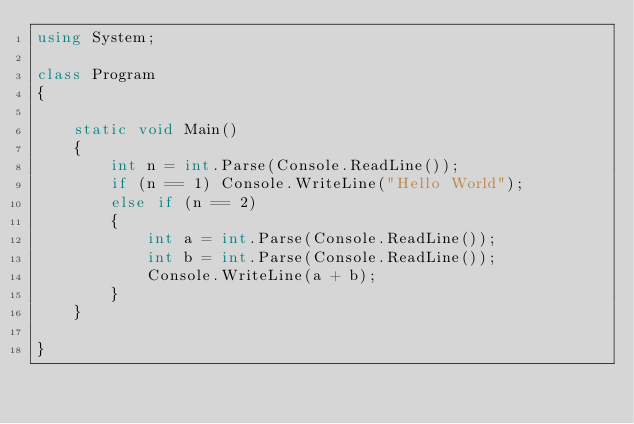<code> <loc_0><loc_0><loc_500><loc_500><_C#_>using System;

class Program
{

    static void Main()
    {
        int n = int.Parse(Console.ReadLine());
        if (n == 1) Console.WriteLine("Hello World");
        else if (n == 2)
        {
            int a = int.Parse(Console.ReadLine());
            int b = int.Parse(Console.ReadLine());
            Console.WriteLine(a + b);
        }
    }

}</code> 